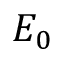<formula> <loc_0><loc_0><loc_500><loc_500>E _ { 0 }</formula> 